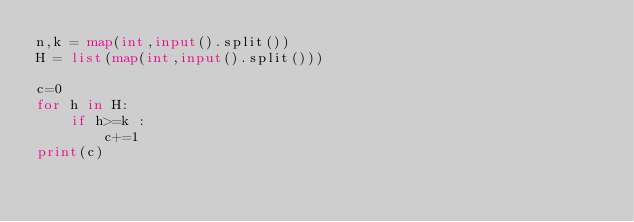Convert code to text. <code><loc_0><loc_0><loc_500><loc_500><_Python_>n,k = map(int,input().split())
H = list(map(int,input().split()))

c=0
for h in H:
    if h>=k :
        c+=1
print(c)</code> 